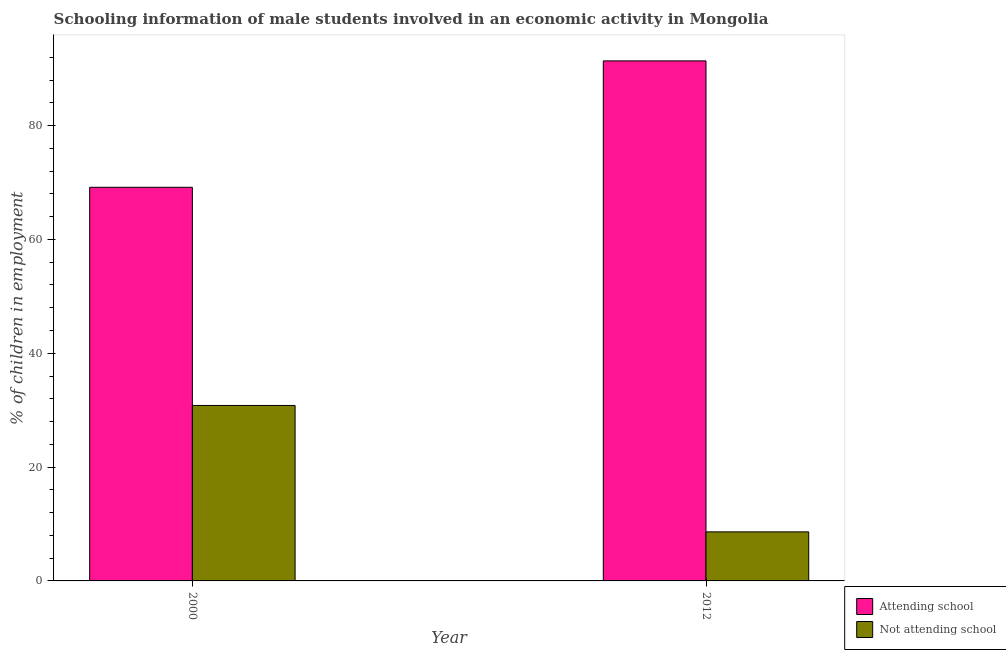How many different coloured bars are there?
Your answer should be compact. 2. How many groups of bars are there?
Make the answer very short. 2. Are the number of bars per tick equal to the number of legend labels?
Provide a succinct answer. Yes. Are the number of bars on each tick of the X-axis equal?
Your answer should be very brief. Yes. How many bars are there on the 2nd tick from the left?
Your answer should be compact. 2. What is the percentage of employed males who are not attending school in 2000?
Offer a very short reply. 30.83. Across all years, what is the maximum percentage of employed males who are not attending school?
Offer a very short reply. 30.83. Across all years, what is the minimum percentage of employed males who are attending school?
Ensure brevity in your answer.  69.17. What is the total percentage of employed males who are attending school in the graph?
Give a very brief answer. 160.55. What is the difference between the percentage of employed males who are attending school in 2000 and that in 2012?
Your answer should be very brief. -22.21. What is the difference between the percentage of employed males who are not attending school in 2012 and the percentage of employed males who are attending school in 2000?
Make the answer very short. -22.21. What is the average percentage of employed males who are not attending school per year?
Your answer should be compact. 19.73. In the year 2000, what is the difference between the percentage of employed males who are attending school and percentage of employed males who are not attending school?
Your answer should be very brief. 0. What is the ratio of the percentage of employed males who are not attending school in 2000 to that in 2012?
Ensure brevity in your answer.  3.58. In how many years, is the percentage of employed males who are attending school greater than the average percentage of employed males who are attending school taken over all years?
Your answer should be very brief. 1. What does the 2nd bar from the left in 2000 represents?
Give a very brief answer. Not attending school. What does the 1st bar from the right in 2012 represents?
Offer a very short reply. Not attending school. Where does the legend appear in the graph?
Your answer should be compact. Bottom right. How many legend labels are there?
Give a very brief answer. 2. What is the title of the graph?
Give a very brief answer. Schooling information of male students involved in an economic activity in Mongolia. Does "Study and work" appear as one of the legend labels in the graph?
Your answer should be compact. No. What is the label or title of the Y-axis?
Ensure brevity in your answer.  % of children in employment. What is the % of children in employment of Attending school in 2000?
Your response must be concise. 69.17. What is the % of children in employment in Not attending school in 2000?
Your answer should be compact. 30.83. What is the % of children in employment of Attending school in 2012?
Provide a succinct answer. 91.38. What is the % of children in employment in Not attending school in 2012?
Make the answer very short. 8.62. Across all years, what is the maximum % of children in employment in Attending school?
Offer a very short reply. 91.38. Across all years, what is the maximum % of children in employment in Not attending school?
Provide a short and direct response. 30.83. Across all years, what is the minimum % of children in employment of Attending school?
Offer a terse response. 69.17. Across all years, what is the minimum % of children in employment of Not attending school?
Offer a very short reply. 8.62. What is the total % of children in employment of Attending school in the graph?
Keep it short and to the point. 160.55. What is the total % of children in employment in Not attending school in the graph?
Keep it short and to the point. 39.45. What is the difference between the % of children in employment in Attending school in 2000 and that in 2012?
Provide a succinct answer. -22.21. What is the difference between the % of children in employment in Not attending school in 2000 and that in 2012?
Your response must be concise. 22.21. What is the difference between the % of children in employment of Attending school in 2000 and the % of children in employment of Not attending school in 2012?
Your response must be concise. 60.55. What is the average % of children in employment in Attending school per year?
Offer a very short reply. 80.27. What is the average % of children in employment in Not attending school per year?
Keep it short and to the point. 19.73. In the year 2000, what is the difference between the % of children in employment of Attending school and % of children in employment of Not attending school?
Your answer should be compact. 38.34. In the year 2012, what is the difference between the % of children in employment in Attending school and % of children in employment in Not attending school?
Offer a very short reply. 82.76. What is the ratio of the % of children in employment in Attending school in 2000 to that in 2012?
Provide a succinct answer. 0.76. What is the ratio of the % of children in employment of Not attending school in 2000 to that in 2012?
Provide a short and direct response. 3.58. What is the difference between the highest and the second highest % of children in employment in Attending school?
Make the answer very short. 22.21. What is the difference between the highest and the second highest % of children in employment in Not attending school?
Your response must be concise. 22.21. What is the difference between the highest and the lowest % of children in employment in Attending school?
Offer a terse response. 22.21. What is the difference between the highest and the lowest % of children in employment in Not attending school?
Keep it short and to the point. 22.21. 